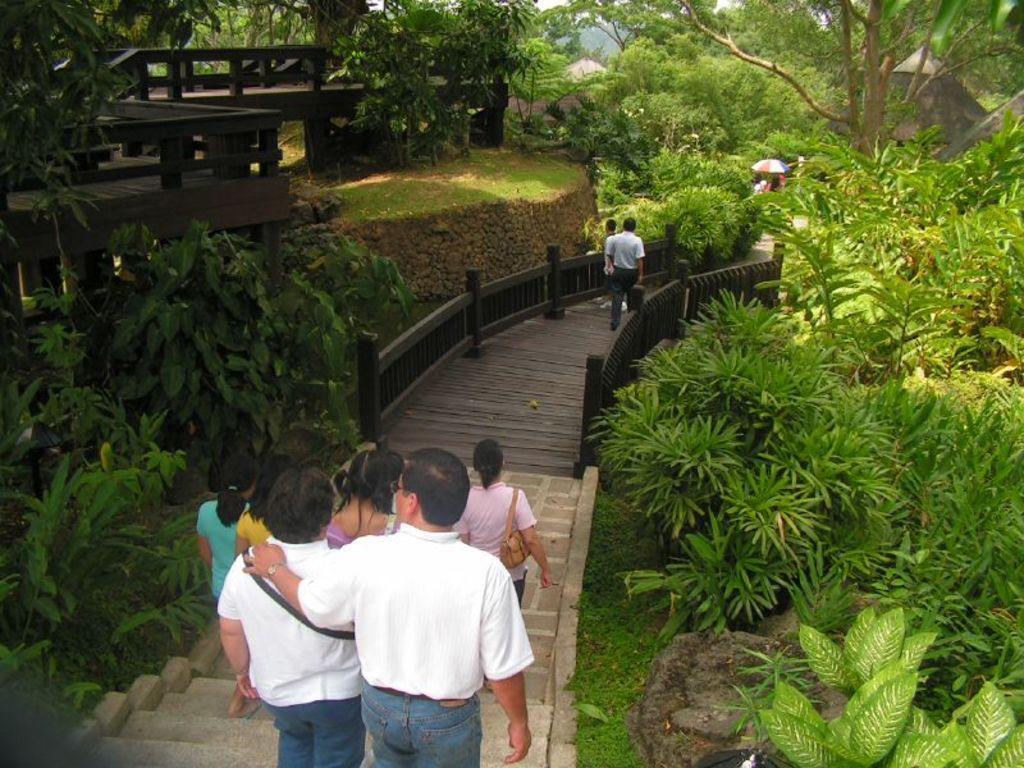Can you describe this image briefly? In this image I can see two persons wearing white shirts and blue jeans are standing on the stairs and few other persons on the stairs. I can see few trees on both sides of the stairs, the black colored railing, some grass, a wooden bridge. In the background I can see the sky and few trees. 